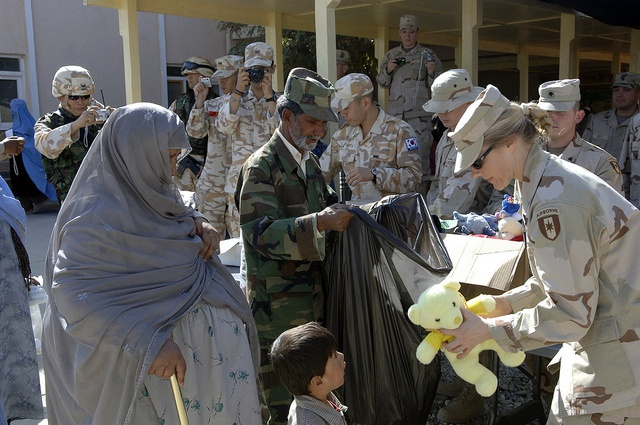Describe the objects in this image and their specific colors. I can see people in gray, black, and darkgray tones, people in gray tones, people in gray, black, and maroon tones, people in gray, black, and maroon tones, and people in gray, black, and darkblue tones in this image. 